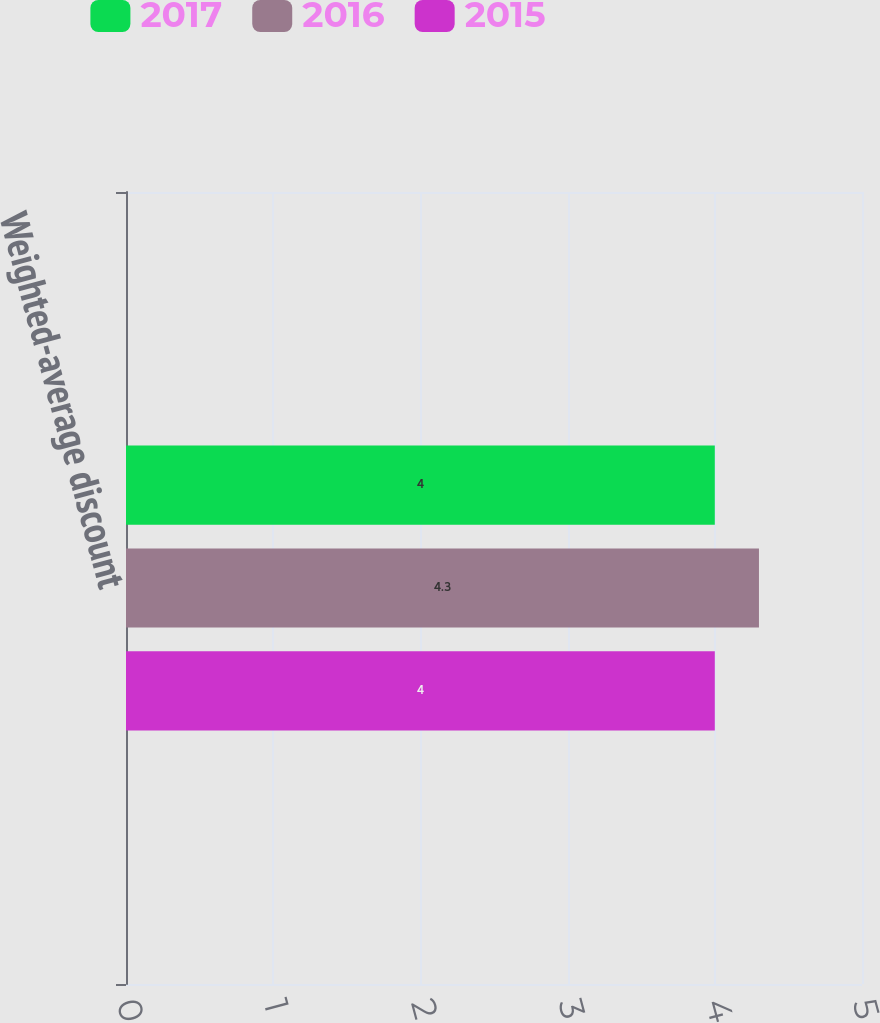<chart> <loc_0><loc_0><loc_500><loc_500><stacked_bar_chart><ecel><fcel>Weighted-average discount<nl><fcel>2017<fcel>4<nl><fcel>2016<fcel>4.3<nl><fcel>2015<fcel>4<nl></chart> 